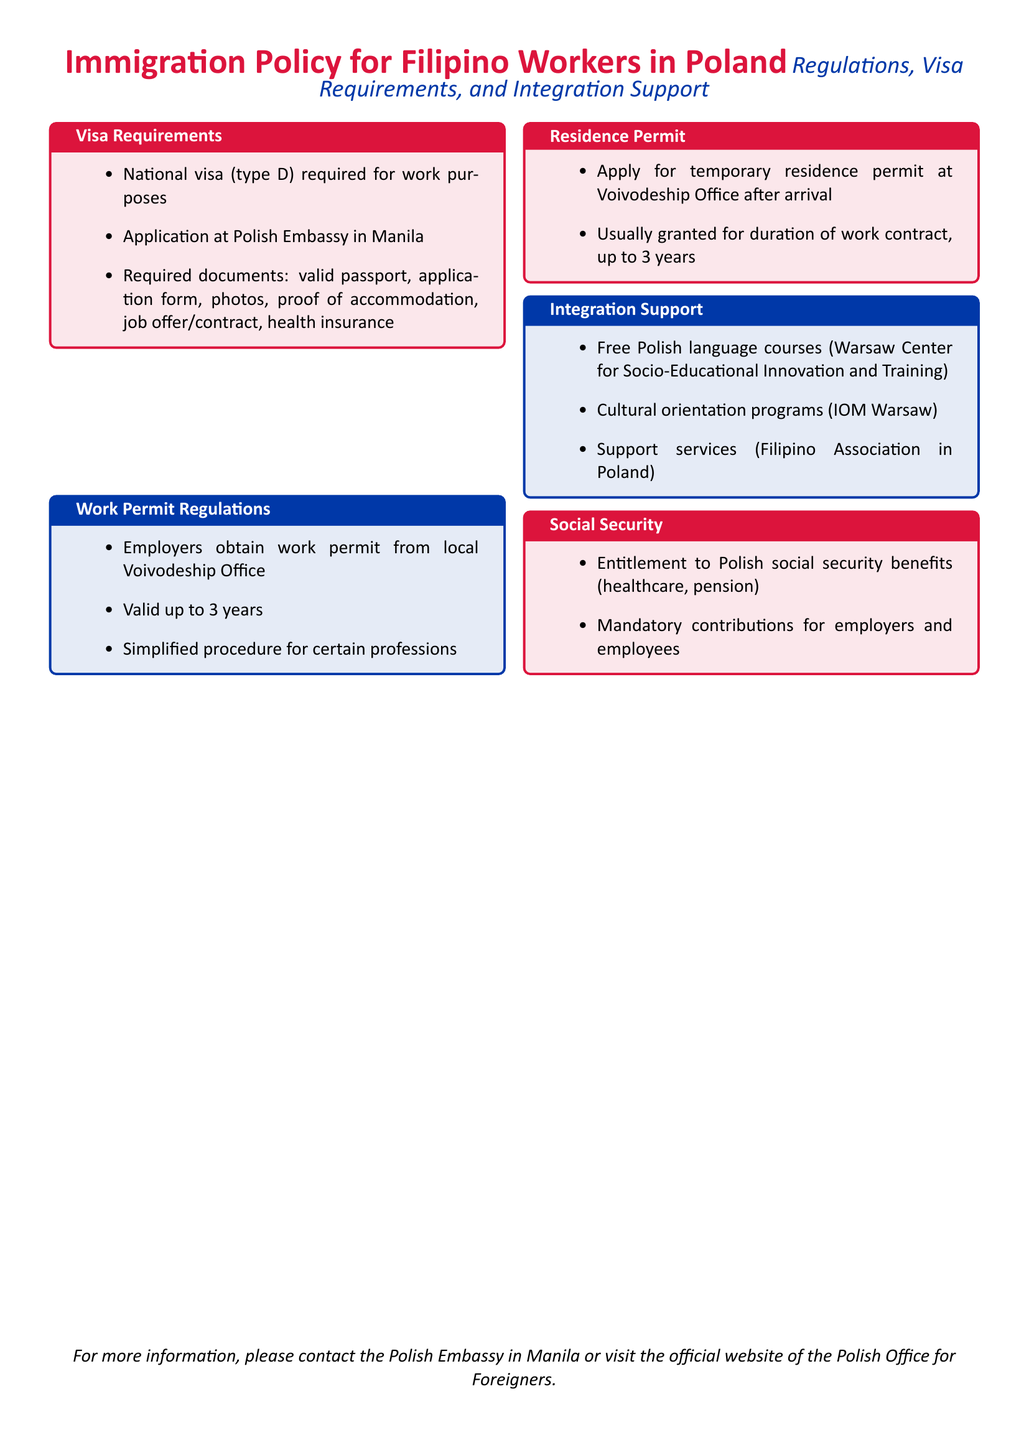What type of visa is required for Filipino workers? The document specifies that a national visa (type D) is required for work purposes.
Answer: national visa (type D) Where should Filipinos apply for their work visa? The document states that applications should be made at the Polish Embassy in Manila.
Answer: Polish Embassy in Manila What is the duration a work permit can be valid for? The document mentions that a work permit can be valid for up to 3 years.
Answer: up to 3 years What is one of the integration support services offered? The document lists free Polish language courses provided by the Warsaw Center for Socio-Educational Innovation and Training as an integration support service.
Answer: free Polish language courses What document is required to apply for a temporary residence permit? The document indicates that an application for a temporary residence permit is required at the Voivodeship Office after arrival.
Answer: Voivodeship Office Who is responsible for mandatory contributions to social security? The document states that mandatory contributions must be made by both employers and employees.
Answer: employers and employees What cultural program is mentioned for Filipino workers? The document mentions cultural orientation programs offered by IOM Warsaw as part of integration support.
Answer: cultural orientation programs Which organization provides support services for Filipino workers? The document indicates that the Filipino Association in Poland provides support services.
Answer: Filipino Association in Poland 